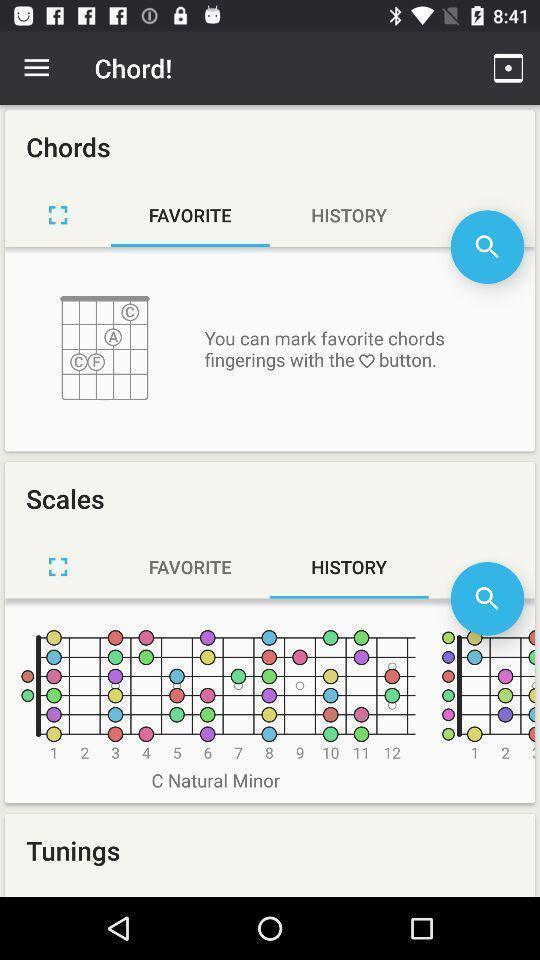Describe the visual elements of this screenshot. Page displays favorite scales and chords for guitar in app. 